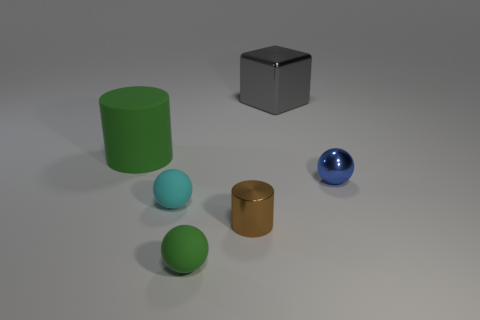Add 2 tiny cylinders. How many objects exist? 8 Subtract all blocks. How many objects are left? 5 Subtract 0 purple cylinders. How many objects are left? 6 Subtract all metallic cylinders. Subtract all cyan things. How many objects are left? 4 Add 6 small green rubber objects. How many small green rubber objects are left? 7 Add 4 big green cylinders. How many big green cylinders exist? 5 